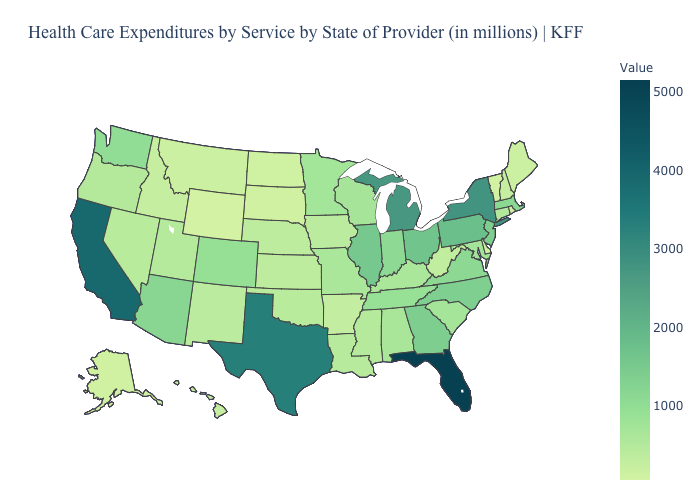Does West Virginia have the highest value in the South?
Concise answer only. No. Among the states that border New Hampshire , which have the lowest value?
Quick response, please. Vermont. Among the states that border New Jersey , which have the lowest value?
Write a very short answer. Delaware. Does the map have missing data?
Be succinct. No. Among the states that border Vermont , does New York have the highest value?
Concise answer only. Yes. Which states have the highest value in the USA?
Answer briefly. Florida. Does Wisconsin have the highest value in the USA?
Answer briefly. No. 